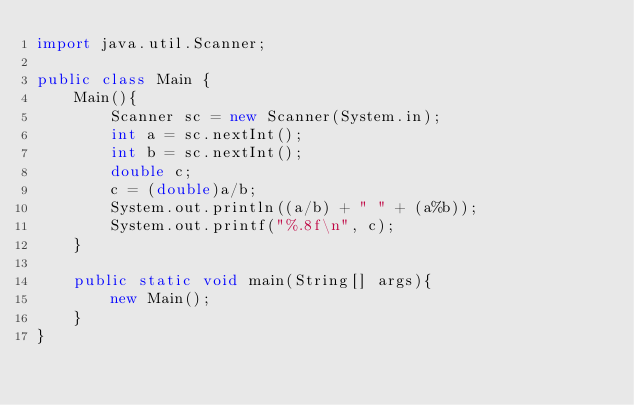<code> <loc_0><loc_0><loc_500><loc_500><_Java_>import java.util.Scanner;

public class Main {
    Main(){
        Scanner sc = new Scanner(System.in);
        int a = sc.nextInt();
        int b = sc.nextInt();
        double c;
        c = (double)a/b;
        System.out.println((a/b) + " " + (a%b));
        System.out.printf("%.8f\n", c);
    }

    public static void main(String[] args){
        new Main();
    }
}

</code> 